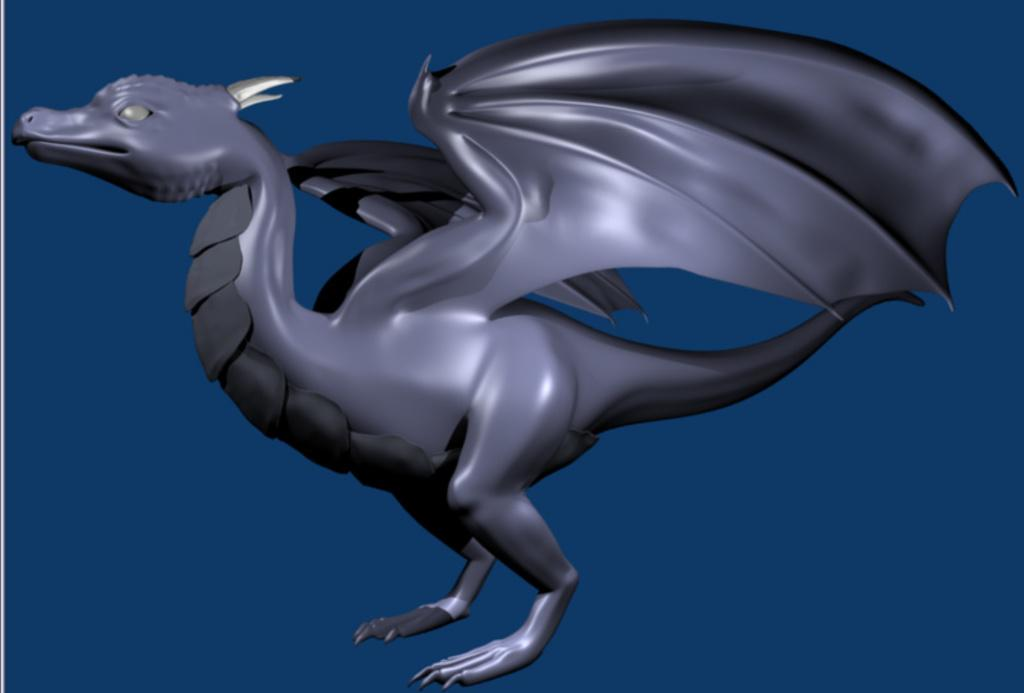What mythical creature is present in the image? The image contains a dragon. What color is the background of the image? The background of the image is blue. What type of produce is being sold at the gate in the image? There is no gate or produce present in the image; it features a dragon and a blue background. 